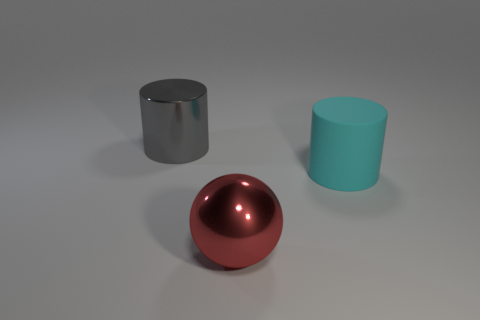How big is the gray thing?
Your answer should be compact. Large. Is the number of large red objects behind the rubber cylinder greater than the number of gray metal things that are on the left side of the gray cylinder?
Ensure brevity in your answer.  No. There is a big thing that is in front of the large cyan rubber object; how many shiny objects are behind it?
Ensure brevity in your answer.  1. There is a big red metallic thing on the left side of the large cyan matte object; does it have the same shape as the large gray thing?
Ensure brevity in your answer.  No. There is a large gray object that is the same shape as the cyan thing; what is its material?
Your response must be concise. Metal. How many cyan cylinders have the same size as the cyan thing?
Provide a succinct answer. 0. There is a thing that is both right of the big metallic cylinder and on the left side of the big cyan rubber object; what is its color?
Your answer should be very brief. Red. Is the number of green matte cylinders less than the number of big shiny cylinders?
Give a very brief answer. Yes. There is a rubber cylinder; is it the same color as the shiny object left of the big ball?
Your answer should be very brief. No. Is the number of cyan things that are in front of the rubber object the same as the number of big cyan rubber cylinders that are behind the big gray cylinder?
Provide a short and direct response. Yes. 